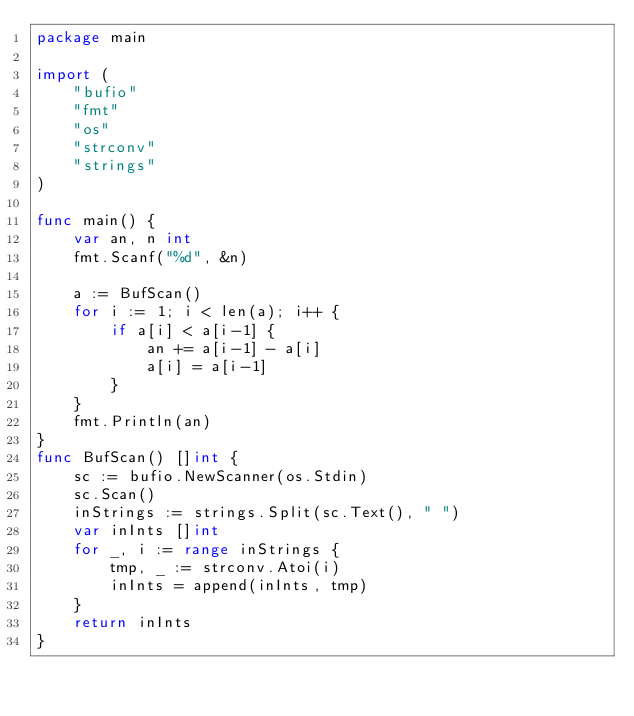Convert code to text. <code><loc_0><loc_0><loc_500><loc_500><_Go_>package main

import (
	"bufio"
	"fmt"
	"os"
	"strconv"
	"strings"
)

func main() {
	var an, n int
	fmt.Scanf("%d", &n)

	a := BufScan()
	for i := 1; i < len(a); i++ {
		if a[i] < a[i-1] {
			an += a[i-1] - a[i]
			a[i] = a[i-1]
		}
	}
	fmt.Println(an)
}
func BufScan() []int {
	sc := bufio.NewScanner(os.Stdin)
	sc.Scan()
	inStrings := strings.Split(sc.Text(), " ")
	var inInts []int
	for _, i := range inStrings {
		tmp, _ := strconv.Atoi(i)
		inInts = append(inInts, tmp)
	}
	return inInts
}
</code> 